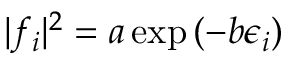Convert formula to latex. <formula><loc_0><loc_0><loc_500><loc_500>| f _ { i } | ^ { 2 } = a \exp { ( - b \epsilon _ { i } ) }</formula> 